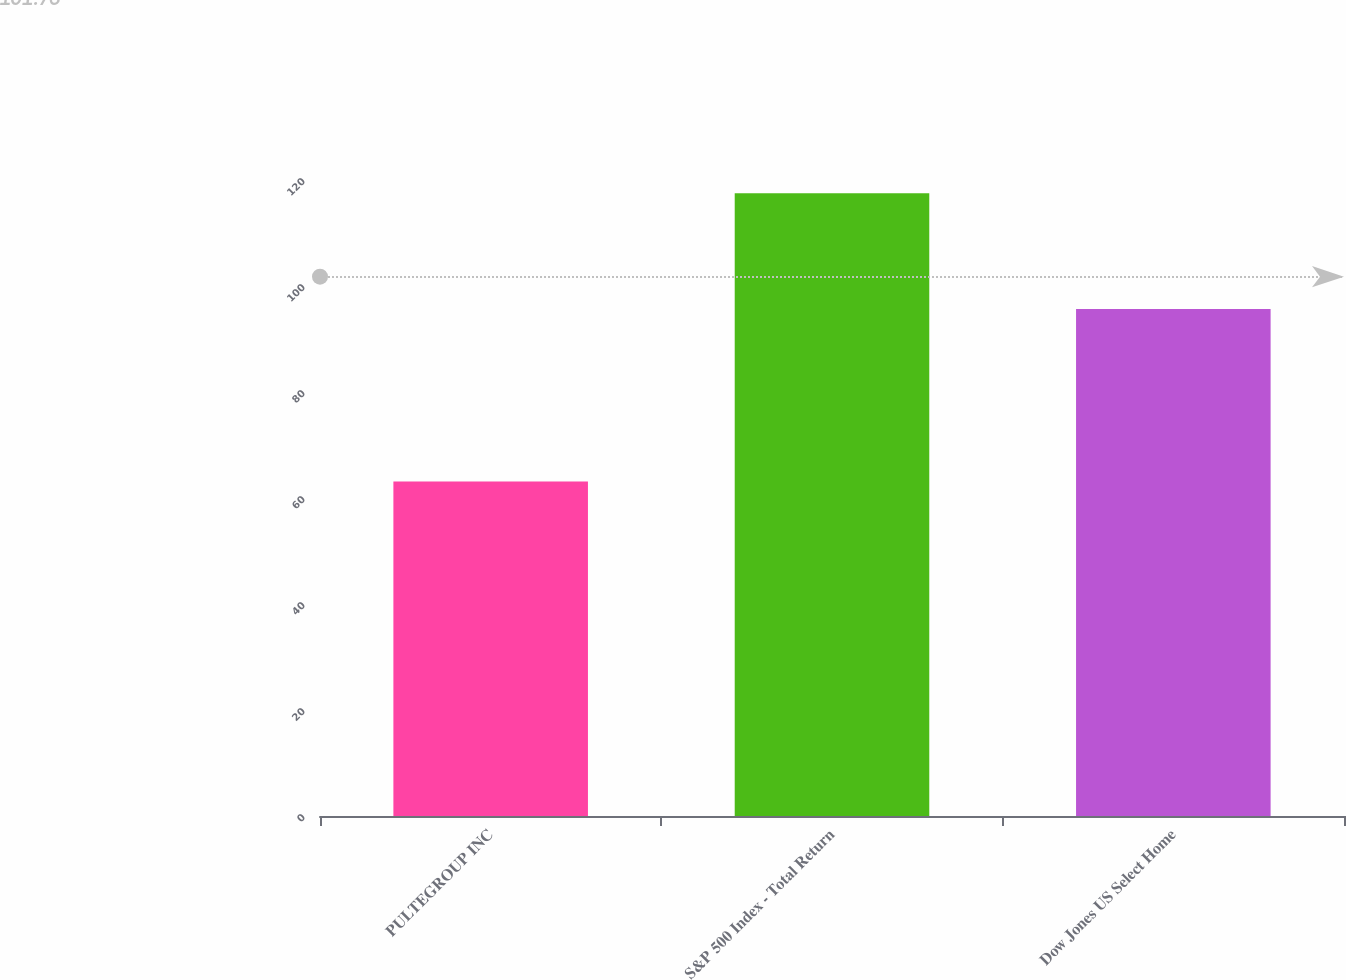Convert chart. <chart><loc_0><loc_0><loc_500><loc_500><bar_chart><fcel>PULTEGROUP INC<fcel>S&P 500 Index - Total Return<fcel>Dow Jones US Select Home<nl><fcel>63.1<fcel>117.49<fcel>95.67<nl></chart> 